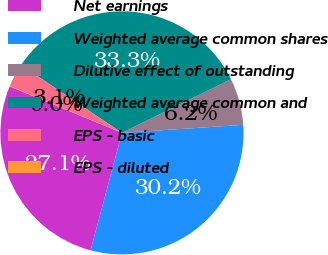Convert chart. <chart><loc_0><loc_0><loc_500><loc_500><pie_chart><fcel>Net earnings<fcel>Weighted average common shares<fcel>Dilutive effect of outstanding<fcel>Weighted average common and<fcel>EPS - basic<fcel>EPS - diluted<nl><fcel>27.09%<fcel>30.2%<fcel>6.23%<fcel>33.3%<fcel>3.13%<fcel>0.04%<nl></chart> 